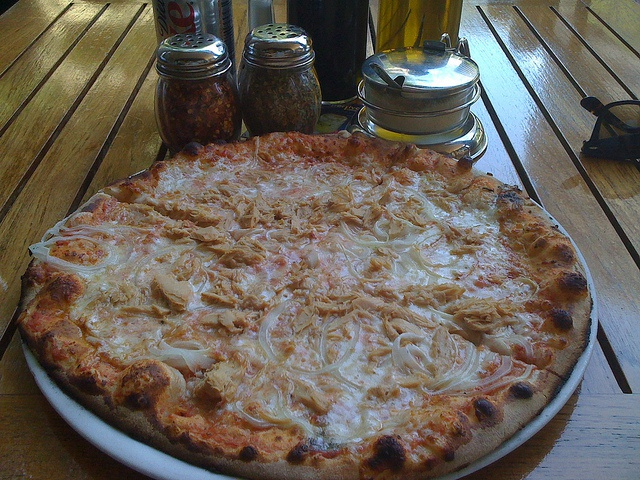Describe the objects in this image and their specific colors. I can see dining table in black, gray, olive, and darkgray tones, pizza in black, darkgray, gray, and maroon tones, bottle in black, maroon, gray, and purple tones, bowl in black, gray, white, and darkgreen tones, and bottle in black, darkgreen, and gray tones in this image. 